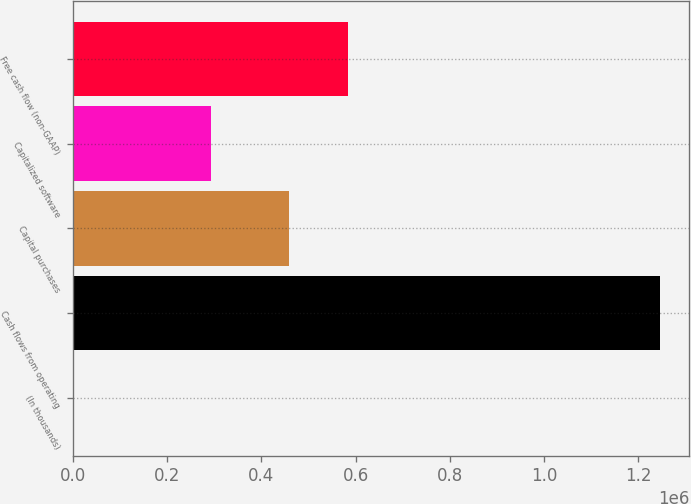Convert chart. <chart><loc_0><loc_0><loc_500><loc_500><bar_chart><fcel>(In thousands)<fcel>Cash flows from operating<fcel>Capital purchases<fcel>Capitalized software<fcel>Free cash flow (non-GAAP)<nl><fcel>2016<fcel>1.24564e+06<fcel>459427<fcel>293696<fcel>583789<nl></chart> 